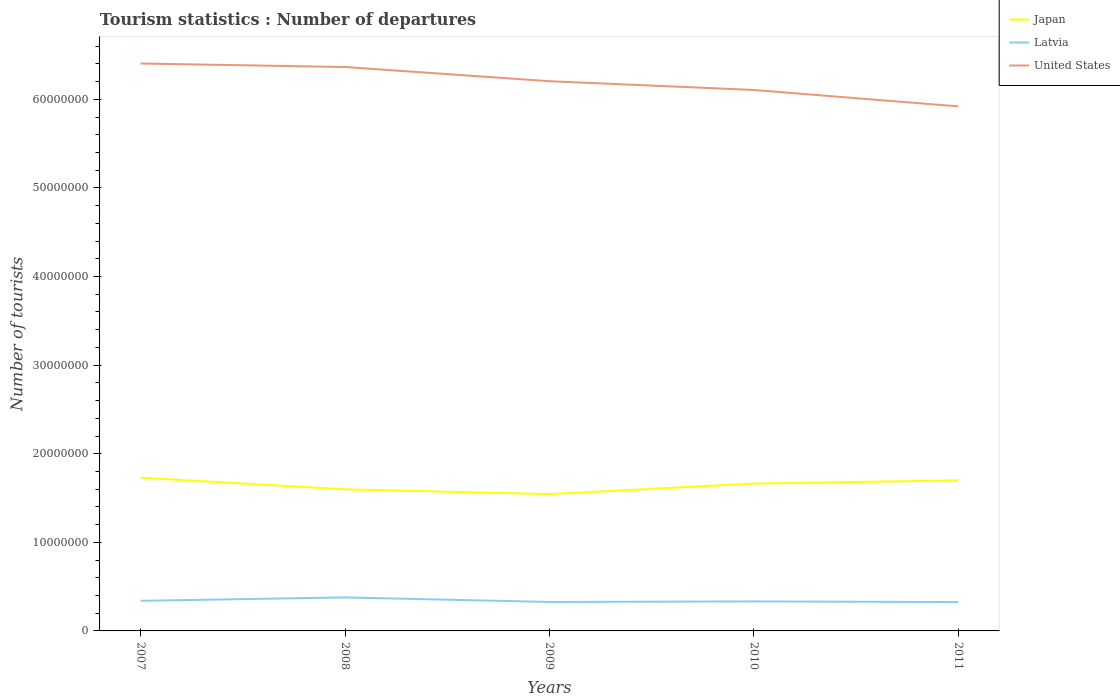How many different coloured lines are there?
Keep it short and to the point. 3. Does the line corresponding to United States intersect with the line corresponding to Japan?
Offer a terse response. No. Across all years, what is the maximum number of tourist departures in Japan?
Offer a very short reply. 1.54e+07. What is the total number of tourist departures in United States in the graph?
Make the answer very short. 2.99e+06. What is the difference between the highest and the second highest number of tourist departures in United States?
Your answer should be very brief. 4.84e+06. What is the difference between the highest and the lowest number of tourist departures in United States?
Keep it short and to the point. 3. How many lines are there?
Your answer should be compact. 3. How many years are there in the graph?
Provide a short and direct response. 5. How many legend labels are there?
Your answer should be very brief. 3. How are the legend labels stacked?
Provide a short and direct response. Vertical. What is the title of the graph?
Provide a succinct answer. Tourism statistics : Number of departures. Does "European Union" appear as one of the legend labels in the graph?
Offer a very short reply. No. What is the label or title of the Y-axis?
Offer a very short reply. Number of tourists. What is the Number of tourists in Japan in 2007?
Ensure brevity in your answer.  1.73e+07. What is the Number of tourists in Latvia in 2007?
Your response must be concise. 3.40e+06. What is the Number of tourists of United States in 2007?
Offer a terse response. 6.40e+07. What is the Number of tourists of Japan in 2008?
Your response must be concise. 1.60e+07. What is the Number of tourists in Latvia in 2008?
Provide a succinct answer. 3.78e+06. What is the Number of tourists of United States in 2008?
Your answer should be very brief. 6.37e+07. What is the Number of tourists of Japan in 2009?
Offer a terse response. 1.54e+07. What is the Number of tourists of Latvia in 2009?
Your answer should be very brief. 3.27e+06. What is the Number of tourists in United States in 2009?
Make the answer very short. 6.21e+07. What is the Number of tourists of Japan in 2010?
Offer a terse response. 1.66e+07. What is the Number of tourists of Latvia in 2010?
Make the answer very short. 3.33e+06. What is the Number of tourists in United States in 2010?
Keep it short and to the point. 6.11e+07. What is the Number of tourists in Japan in 2011?
Your answer should be very brief. 1.70e+07. What is the Number of tourists of Latvia in 2011?
Your response must be concise. 3.26e+06. What is the Number of tourists of United States in 2011?
Your response must be concise. 5.92e+07. Across all years, what is the maximum Number of tourists of Japan?
Provide a short and direct response. 1.73e+07. Across all years, what is the maximum Number of tourists in Latvia?
Your answer should be very brief. 3.78e+06. Across all years, what is the maximum Number of tourists in United States?
Your response must be concise. 6.40e+07. Across all years, what is the minimum Number of tourists of Japan?
Provide a succinct answer. 1.54e+07. Across all years, what is the minimum Number of tourists of Latvia?
Offer a very short reply. 3.26e+06. Across all years, what is the minimum Number of tourists of United States?
Offer a very short reply. 5.92e+07. What is the total Number of tourists in Japan in the graph?
Offer a very short reply. 8.24e+07. What is the total Number of tourists of Latvia in the graph?
Offer a terse response. 1.70e+07. What is the total Number of tourists of United States in the graph?
Make the answer very short. 3.10e+08. What is the difference between the Number of tourists of Japan in 2007 and that in 2008?
Offer a very short reply. 1.31e+06. What is the difference between the Number of tourists in Latvia in 2007 and that in 2008?
Offer a terse response. -3.84e+05. What is the difference between the Number of tourists of United States in 2007 and that in 2008?
Your response must be concise. 3.96e+05. What is the difference between the Number of tourists of Japan in 2007 and that in 2009?
Your response must be concise. 1.85e+06. What is the difference between the Number of tourists of Latvia in 2007 and that in 2009?
Your response must be concise. 1.30e+05. What is the difference between the Number of tourists of United States in 2007 and that in 2009?
Make the answer very short. 2.00e+06. What is the difference between the Number of tourists of Japan in 2007 and that in 2010?
Give a very brief answer. 6.58e+05. What is the difference between the Number of tourists of Latvia in 2007 and that in 2010?
Offer a terse response. 6.60e+04. What is the difference between the Number of tourists in United States in 2007 and that in 2010?
Offer a terse response. 2.99e+06. What is the difference between the Number of tourists in Japan in 2007 and that in 2011?
Offer a terse response. 3.01e+05. What is the difference between the Number of tourists of Latvia in 2007 and that in 2011?
Ensure brevity in your answer.  1.41e+05. What is the difference between the Number of tourists in United States in 2007 and that in 2011?
Your answer should be compact. 4.84e+06. What is the difference between the Number of tourists in Japan in 2008 and that in 2009?
Provide a succinct answer. 5.41e+05. What is the difference between the Number of tourists in Latvia in 2008 and that in 2009?
Provide a succinct answer. 5.14e+05. What is the difference between the Number of tourists in United States in 2008 and that in 2009?
Your answer should be compact. 1.60e+06. What is the difference between the Number of tourists of Japan in 2008 and that in 2010?
Your response must be concise. -6.50e+05. What is the difference between the Number of tourists of Latvia in 2008 and that in 2010?
Make the answer very short. 4.50e+05. What is the difference between the Number of tourists of United States in 2008 and that in 2010?
Your response must be concise. 2.59e+06. What is the difference between the Number of tourists of Japan in 2008 and that in 2011?
Offer a very short reply. -1.01e+06. What is the difference between the Number of tourists of Latvia in 2008 and that in 2011?
Offer a terse response. 5.25e+05. What is the difference between the Number of tourists of United States in 2008 and that in 2011?
Your answer should be compact. 4.44e+06. What is the difference between the Number of tourists of Japan in 2009 and that in 2010?
Offer a terse response. -1.19e+06. What is the difference between the Number of tourists of Latvia in 2009 and that in 2010?
Provide a short and direct response. -6.40e+04. What is the difference between the Number of tourists in United States in 2009 and that in 2010?
Offer a very short reply. 9.90e+05. What is the difference between the Number of tourists of Japan in 2009 and that in 2011?
Your response must be concise. -1.55e+06. What is the difference between the Number of tourists of Latvia in 2009 and that in 2011?
Your answer should be compact. 1.10e+04. What is the difference between the Number of tourists of United States in 2009 and that in 2011?
Offer a terse response. 2.84e+06. What is the difference between the Number of tourists in Japan in 2010 and that in 2011?
Offer a very short reply. -3.57e+05. What is the difference between the Number of tourists in Latvia in 2010 and that in 2011?
Provide a short and direct response. 7.50e+04. What is the difference between the Number of tourists in United States in 2010 and that in 2011?
Your answer should be very brief. 1.85e+06. What is the difference between the Number of tourists of Japan in 2007 and the Number of tourists of Latvia in 2008?
Give a very brief answer. 1.35e+07. What is the difference between the Number of tourists in Japan in 2007 and the Number of tourists in United States in 2008?
Your response must be concise. -4.64e+07. What is the difference between the Number of tourists of Latvia in 2007 and the Number of tourists of United States in 2008?
Your response must be concise. -6.03e+07. What is the difference between the Number of tourists of Japan in 2007 and the Number of tourists of Latvia in 2009?
Your answer should be compact. 1.40e+07. What is the difference between the Number of tourists of Japan in 2007 and the Number of tourists of United States in 2009?
Your answer should be very brief. -4.48e+07. What is the difference between the Number of tourists of Latvia in 2007 and the Number of tourists of United States in 2009?
Offer a very short reply. -5.87e+07. What is the difference between the Number of tourists in Japan in 2007 and the Number of tourists in Latvia in 2010?
Offer a very short reply. 1.40e+07. What is the difference between the Number of tourists in Japan in 2007 and the Number of tourists in United States in 2010?
Provide a short and direct response. -4.38e+07. What is the difference between the Number of tourists of Latvia in 2007 and the Number of tourists of United States in 2010?
Your answer should be compact. -5.77e+07. What is the difference between the Number of tourists in Japan in 2007 and the Number of tourists in Latvia in 2011?
Offer a very short reply. 1.40e+07. What is the difference between the Number of tourists in Japan in 2007 and the Number of tourists in United States in 2011?
Give a very brief answer. -4.19e+07. What is the difference between the Number of tourists in Latvia in 2007 and the Number of tourists in United States in 2011?
Ensure brevity in your answer.  -5.58e+07. What is the difference between the Number of tourists in Japan in 2008 and the Number of tourists in Latvia in 2009?
Give a very brief answer. 1.27e+07. What is the difference between the Number of tourists of Japan in 2008 and the Number of tourists of United States in 2009?
Provide a succinct answer. -4.61e+07. What is the difference between the Number of tourists in Latvia in 2008 and the Number of tourists in United States in 2009?
Provide a succinct answer. -5.83e+07. What is the difference between the Number of tourists of Japan in 2008 and the Number of tourists of Latvia in 2010?
Your answer should be very brief. 1.27e+07. What is the difference between the Number of tourists in Japan in 2008 and the Number of tourists in United States in 2010?
Your response must be concise. -4.51e+07. What is the difference between the Number of tourists of Latvia in 2008 and the Number of tourists of United States in 2010?
Offer a very short reply. -5.73e+07. What is the difference between the Number of tourists in Japan in 2008 and the Number of tourists in Latvia in 2011?
Your response must be concise. 1.27e+07. What is the difference between the Number of tourists in Japan in 2008 and the Number of tourists in United States in 2011?
Your answer should be very brief. -4.32e+07. What is the difference between the Number of tourists in Latvia in 2008 and the Number of tourists in United States in 2011?
Provide a short and direct response. -5.54e+07. What is the difference between the Number of tourists of Japan in 2009 and the Number of tourists of Latvia in 2010?
Keep it short and to the point. 1.21e+07. What is the difference between the Number of tourists in Japan in 2009 and the Number of tourists in United States in 2010?
Your answer should be very brief. -4.56e+07. What is the difference between the Number of tourists in Latvia in 2009 and the Number of tourists in United States in 2010?
Keep it short and to the point. -5.78e+07. What is the difference between the Number of tourists of Japan in 2009 and the Number of tourists of Latvia in 2011?
Provide a succinct answer. 1.22e+07. What is the difference between the Number of tourists in Japan in 2009 and the Number of tourists in United States in 2011?
Provide a succinct answer. -4.38e+07. What is the difference between the Number of tourists of Latvia in 2009 and the Number of tourists of United States in 2011?
Your response must be concise. -5.59e+07. What is the difference between the Number of tourists in Japan in 2010 and the Number of tourists in Latvia in 2011?
Your answer should be compact. 1.34e+07. What is the difference between the Number of tourists in Japan in 2010 and the Number of tourists in United States in 2011?
Provide a short and direct response. -4.26e+07. What is the difference between the Number of tourists in Latvia in 2010 and the Number of tourists in United States in 2011?
Offer a terse response. -5.59e+07. What is the average Number of tourists in Japan per year?
Ensure brevity in your answer.  1.65e+07. What is the average Number of tourists in Latvia per year?
Keep it short and to the point. 3.41e+06. What is the average Number of tourists of United States per year?
Your answer should be compact. 6.20e+07. In the year 2007, what is the difference between the Number of tourists of Japan and Number of tourists of Latvia?
Your answer should be compact. 1.39e+07. In the year 2007, what is the difference between the Number of tourists in Japan and Number of tourists in United States?
Your response must be concise. -4.68e+07. In the year 2007, what is the difference between the Number of tourists of Latvia and Number of tourists of United States?
Keep it short and to the point. -6.07e+07. In the year 2008, what is the difference between the Number of tourists of Japan and Number of tourists of Latvia?
Your response must be concise. 1.22e+07. In the year 2008, what is the difference between the Number of tourists of Japan and Number of tourists of United States?
Provide a succinct answer. -4.77e+07. In the year 2008, what is the difference between the Number of tourists in Latvia and Number of tourists in United States?
Your answer should be compact. -5.99e+07. In the year 2009, what is the difference between the Number of tourists in Japan and Number of tourists in Latvia?
Offer a terse response. 1.22e+07. In the year 2009, what is the difference between the Number of tourists in Japan and Number of tourists in United States?
Offer a terse response. -4.66e+07. In the year 2009, what is the difference between the Number of tourists of Latvia and Number of tourists of United States?
Keep it short and to the point. -5.88e+07. In the year 2010, what is the difference between the Number of tourists in Japan and Number of tourists in Latvia?
Provide a succinct answer. 1.33e+07. In the year 2010, what is the difference between the Number of tourists in Japan and Number of tourists in United States?
Offer a terse response. -4.44e+07. In the year 2010, what is the difference between the Number of tourists of Latvia and Number of tourists of United States?
Give a very brief answer. -5.77e+07. In the year 2011, what is the difference between the Number of tourists in Japan and Number of tourists in Latvia?
Offer a very short reply. 1.37e+07. In the year 2011, what is the difference between the Number of tourists in Japan and Number of tourists in United States?
Make the answer very short. -4.22e+07. In the year 2011, what is the difference between the Number of tourists in Latvia and Number of tourists in United States?
Provide a short and direct response. -5.60e+07. What is the ratio of the Number of tourists in Japan in 2007 to that in 2008?
Make the answer very short. 1.08. What is the ratio of the Number of tourists in Latvia in 2007 to that in 2008?
Provide a short and direct response. 0.9. What is the ratio of the Number of tourists in United States in 2007 to that in 2008?
Make the answer very short. 1.01. What is the ratio of the Number of tourists of Japan in 2007 to that in 2009?
Ensure brevity in your answer.  1.12. What is the ratio of the Number of tourists of Latvia in 2007 to that in 2009?
Offer a very short reply. 1.04. What is the ratio of the Number of tourists in United States in 2007 to that in 2009?
Offer a very short reply. 1.03. What is the ratio of the Number of tourists of Japan in 2007 to that in 2010?
Give a very brief answer. 1.04. What is the ratio of the Number of tourists of Latvia in 2007 to that in 2010?
Make the answer very short. 1.02. What is the ratio of the Number of tourists of United States in 2007 to that in 2010?
Keep it short and to the point. 1.05. What is the ratio of the Number of tourists in Japan in 2007 to that in 2011?
Make the answer very short. 1.02. What is the ratio of the Number of tourists of Latvia in 2007 to that in 2011?
Keep it short and to the point. 1.04. What is the ratio of the Number of tourists in United States in 2007 to that in 2011?
Your answer should be compact. 1.08. What is the ratio of the Number of tourists in Japan in 2008 to that in 2009?
Ensure brevity in your answer.  1.03. What is the ratio of the Number of tourists in Latvia in 2008 to that in 2009?
Ensure brevity in your answer.  1.16. What is the ratio of the Number of tourists in United States in 2008 to that in 2009?
Keep it short and to the point. 1.03. What is the ratio of the Number of tourists of Japan in 2008 to that in 2010?
Provide a short and direct response. 0.96. What is the ratio of the Number of tourists of Latvia in 2008 to that in 2010?
Make the answer very short. 1.14. What is the ratio of the Number of tourists in United States in 2008 to that in 2010?
Keep it short and to the point. 1.04. What is the ratio of the Number of tourists of Japan in 2008 to that in 2011?
Your answer should be very brief. 0.94. What is the ratio of the Number of tourists in Latvia in 2008 to that in 2011?
Provide a succinct answer. 1.16. What is the ratio of the Number of tourists in United States in 2008 to that in 2011?
Ensure brevity in your answer.  1.08. What is the ratio of the Number of tourists in Japan in 2009 to that in 2010?
Provide a short and direct response. 0.93. What is the ratio of the Number of tourists of Latvia in 2009 to that in 2010?
Your answer should be very brief. 0.98. What is the ratio of the Number of tourists in United States in 2009 to that in 2010?
Your answer should be very brief. 1.02. What is the ratio of the Number of tourists of Japan in 2009 to that in 2011?
Make the answer very short. 0.91. What is the ratio of the Number of tourists in United States in 2009 to that in 2011?
Your response must be concise. 1.05. What is the ratio of the Number of tourists of Japan in 2010 to that in 2011?
Your answer should be compact. 0.98. What is the ratio of the Number of tourists in Latvia in 2010 to that in 2011?
Keep it short and to the point. 1.02. What is the ratio of the Number of tourists of United States in 2010 to that in 2011?
Provide a short and direct response. 1.03. What is the difference between the highest and the second highest Number of tourists in Japan?
Your response must be concise. 3.01e+05. What is the difference between the highest and the second highest Number of tourists in Latvia?
Make the answer very short. 3.84e+05. What is the difference between the highest and the second highest Number of tourists in United States?
Give a very brief answer. 3.96e+05. What is the difference between the highest and the lowest Number of tourists in Japan?
Provide a short and direct response. 1.85e+06. What is the difference between the highest and the lowest Number of tourists in Latvia?
Make the answer very short. 5.25e+05. What is the difference between the highest and the lowest Number of tourists of United States?
Make the answer very short. 4.84e+06. 